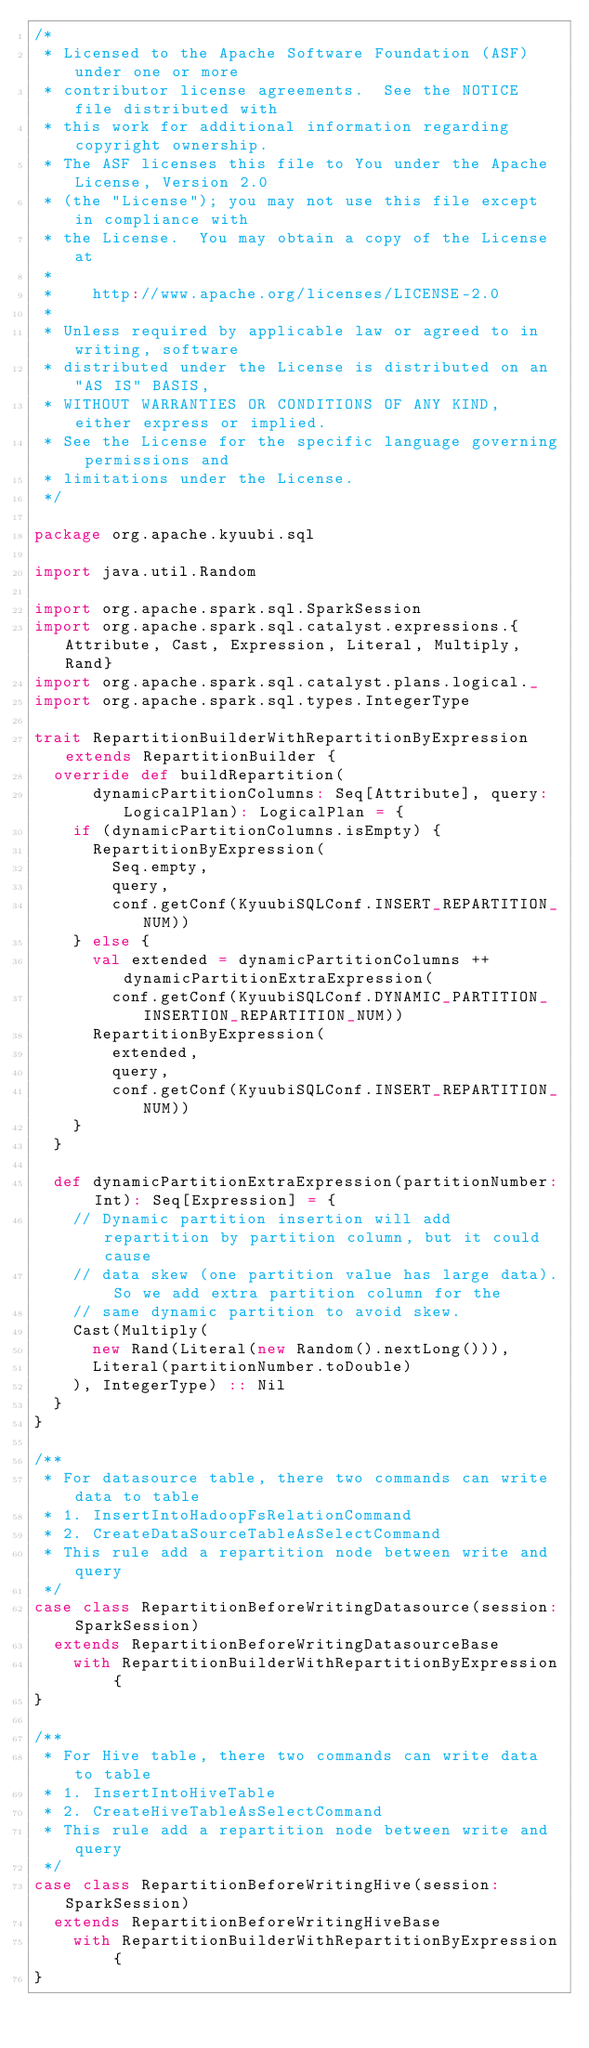Convert code to text. <code><loc_0><loc_0><loc_500><loc_500><_Scala_>/*
 * Licensed to the Apache Software Foundation (ASF) under one or more
 * contributor license agreements.  See the NOTICE file distributed with
 * this work for additional information regarding copyright ownership.
 * The ASF licenses this file to You under the Apache License, Version 2.0
 * (the "License"); you may not use this file except in compliance with
 * the License.  You may obtain a copy of the License at
 *
 *    http://www.apache.org/licenses/LICENSE-2.0
 *
 * Unless required by applicable law or agreed to in writing, software
 * distributed under the License is distributed on an "AS IS" BASIS,
 * WITHOUT WARRANTIES OR CONDITIONS OF ANY KIND, either express or implied.
 * See the License for the specific language governing permissions and
 * limitations under the License.
 */

package org.apache.kyuubi.sql

import java.util.Random

import org.apache.spark.sql.SparkSession
import org.apache.spark.sql.catalyst.expressions.{Attribute, Cast, Expression, Literal, Multiply, Rand}
import org.apache.spark.sql.catalyst.plans.logical._
import org.apache.spark.sql.types.IntegerType

trait RepartitionBuilderWithRepartitionByExpression extends RepartitionBuilder {
  override def buildRepartition(
      dynamicPartitionColumns: Seq[Attribute], query: LogicalPlan): LogicalPlan = {
    if (dynamicPartitionColumns.isEmpty) {
      RepartitionByExpression(
        Seq.empty,
        query,
        conf.getConf(KyuubiSQLConf.INSERT_REPARTITION_NUM))
    } else {
      val extended = dynamicPartitionColumns ++ dynamicPartitionExtraExpression(
        conf.getConf(KyuubiSQLConf.DYNAMIC_PARTITION_INSERTION_REPARTITION_NUM))
      RepartitionByExpression(
        extended,
        query,
        conf.getConf(KyuubiSQLConf.INSERT_REPARTITION_NUM))
    }
  }

  def dynamicPartitionExtraExpression(partitionNumber: Int): Seq[Expression] = {
    // Dynamic partition insertion will add repartition by partition column, but it could cause
    // data skew (one partition value has large data). So we add extra partition column for the
    // same dynamic partition to avoid skew.
    Cast(Multiply(
      new Rand(Literal(new Random().nextLong())),
      Literal(partitionNumber.toDouble)
    ), IntegerType) :: Nil
  }
}

/**
 * For datasource table, there two commands can write data to table
 * 1. InsertIntoHadoopFsRelationCommand
 * 2. CreateDataSourceTableAsSelectCommand
 * This rule add a repartition node between write and query
 */
case class RepartitionBeforeWritingDatasource(session: SparkSession)
  extends RepartitionBeforeWritingDatasourceBase
    with RepartitionBuilderWithRepartitionByExpression {
}

/**
 * For Hive table, there two commands can write data to table
 * 1. InsertIntoHiveTable
 * 2. CreateHiveTableAsSelectCommand
 * This rule add a repartition node between write and query
 */
case class RepartitionBeforeWritingHive(session: SparkSession)
  extends RepartitionBeforeWritingHiveBase
    with RepartitionBuilderWithRepartitionByExpression {
}
</code> 